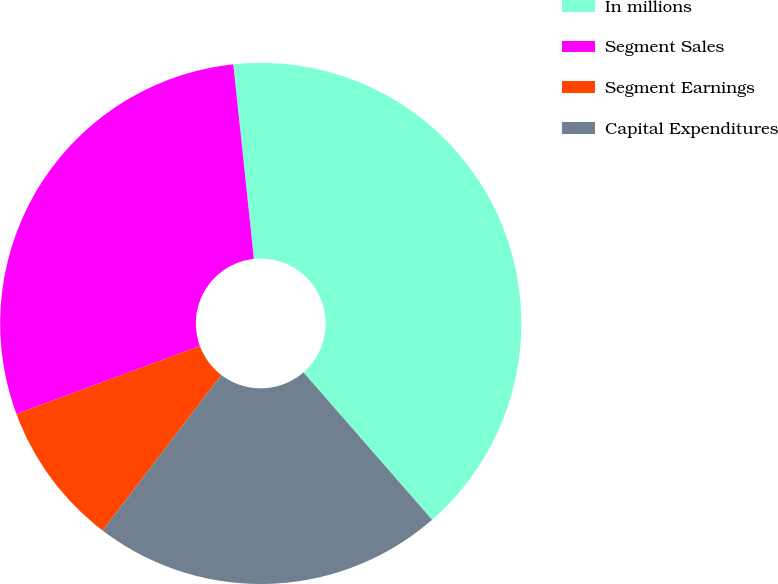Convert chart to OTSL. <chart><loc_0><loc_0><loc_500><loc_500><pie_chart><fcel>In millions<fcel>Segment Sales<fcel>Segment Earnings<fcel>Capital Expenditures<nl><fcel>40.26%<fcel>28.97%<fcel>8.97%<fcel>21.8%<nl></chart> 